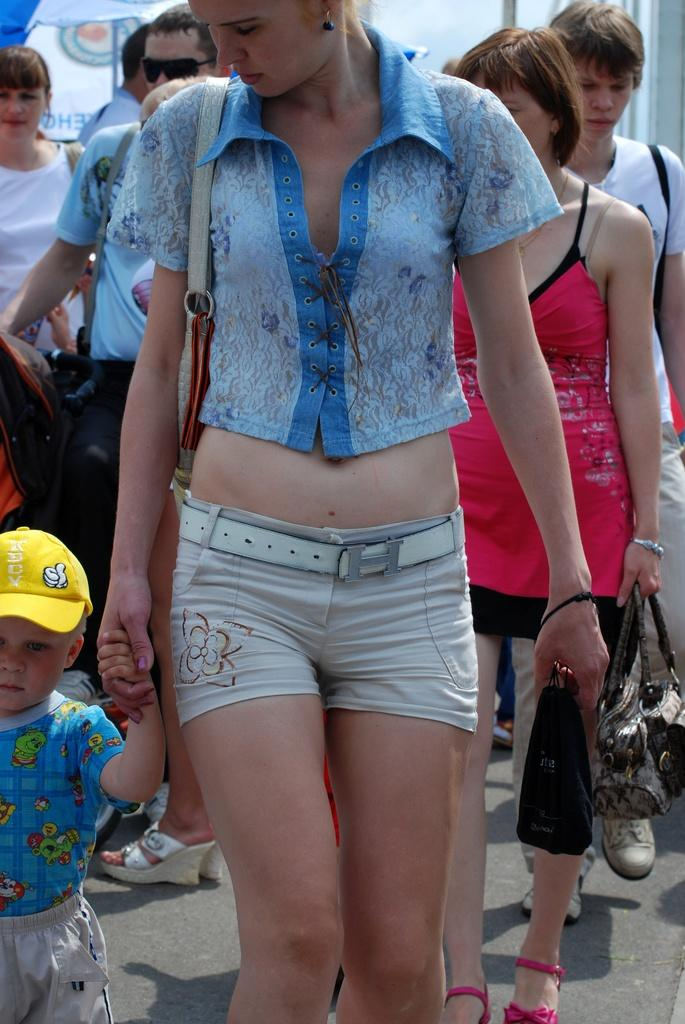How many people are in the image? There are people in the image. What is the woman holding in the image? The woman is holding an object. What else is the woman doing in the image? The woman is also holding a child's hand. What type of trick is the woman teaching the child in the image? There is no trick being taught in the image; the woman is simply holding a child's hand. 